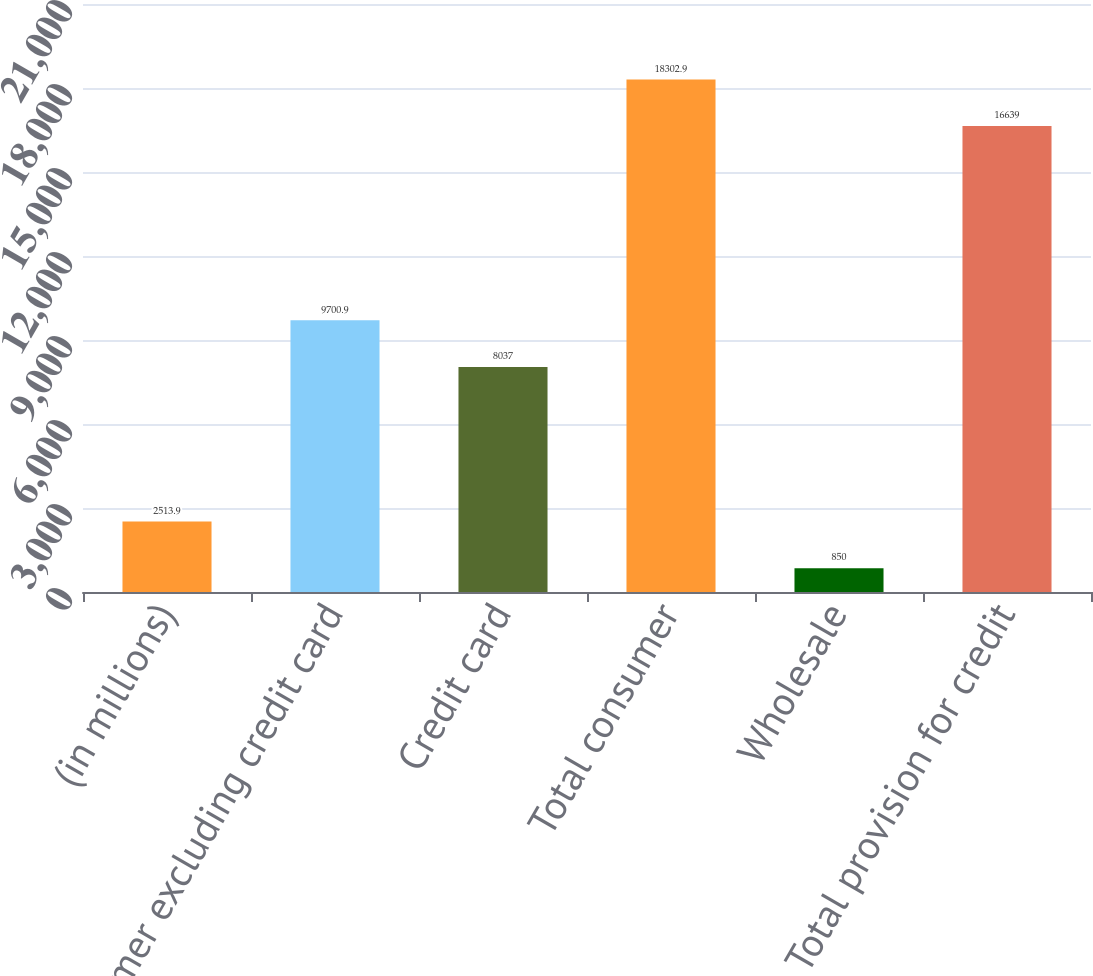Convert chart to OTSL. <chart><loc_0><loc_0><loc_500><loc_500><bar_chart><fcel>(in millions)<fcel>Consumer excluding credit card<fcel>Credit card<fcel>Total consumer<fcel>Wholesale<fcel>Total provision for credit<nl><fcel>2513.9<fcel>9700.9<fcel>8037<fcel>18302.9<fcel>850<fcel>16639<nl></chart> 